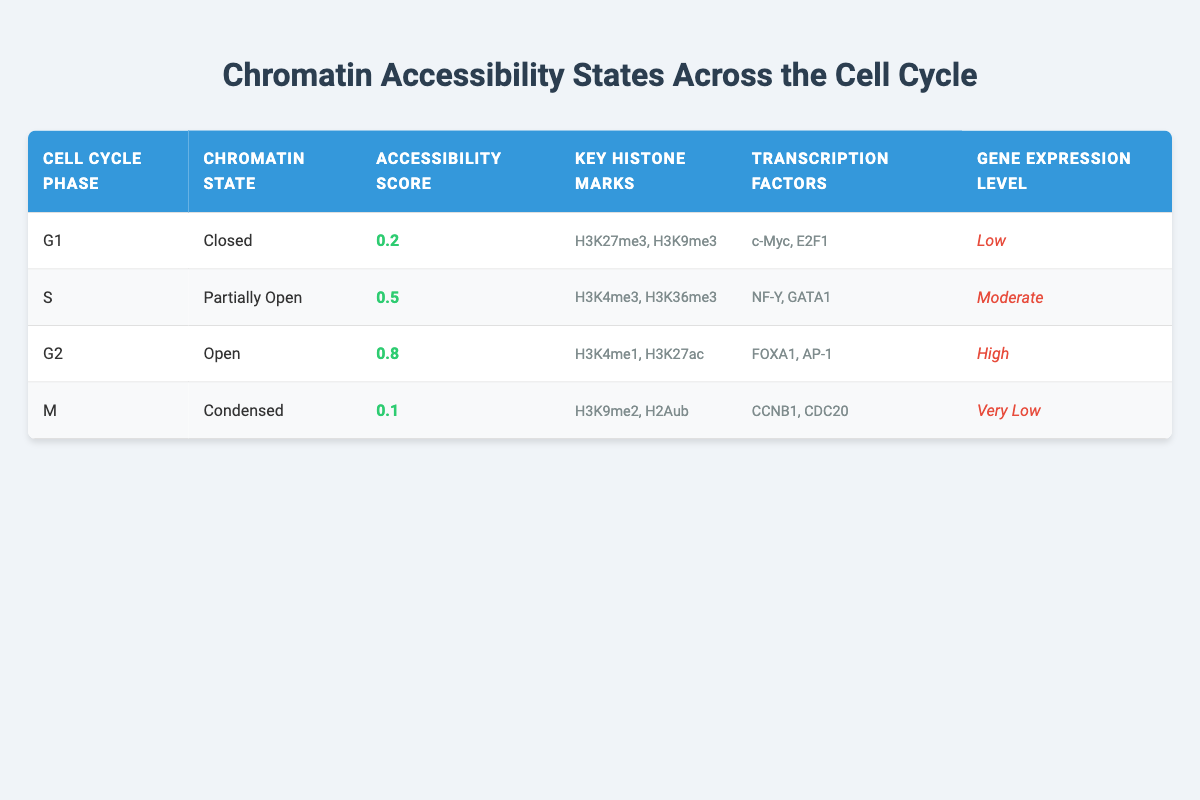What is the accessibility score during the G2 phase? In the table, for the G2 phase, the accessibility score is clearly stated as 0.8.
Answer: 0.8 Which chromatin state is associated with the lowest gene expression level? The table indicates that the M phase has a chromatin state of "Condensed" and a gene expression level described as "Very Low."
Answer: Condensed Is the chromatin state for S phase partially open? According to the information in the S phase row, the chromatin state is described as "Partially Open," so the statement is true.
Answer: Yes What are the key histone marks present during the G1 phase? The G1 phase entry lists the key histone marks as H3K27me3 and H3K9me3.
Answer: H3K27me3, H3K9me3 Based on the table, what is the average accessibility score across all phases? The scores for all phases are: G1 = 0.2, S = 0.5, G2 = 0.8, M = 0.1. The sum is 0.2 + 0.5 + 0.8 + 0.1 = 1.6, and there are 4 phases, so the average accessibility score is 1.6 divided by 4, which equals 0.4.
Answer: 0.4 During which phase is the accessibility score higher than 0.5? The table shows that only the G2 phase has an accessibility score of 0.8, which is greater than 0.5.
Answer: G2 How many transcription factors are listed for the S phase? In the S phase row, there are two transcription factors mentioned: NF-Y and GATA1.
Answer: 2 True or False: The G1 phase has a higher accessibility score than M phase. The accessibility scores for G1 and M phases are 0.2 and 0.1 respectively, so G1 does have a higher score. Thus, the statement is true.
Answer: True What is the relationship between chromatin state and gene expression level in the G2 phase? In the G2 phase, the chromatin state is "Open," and it correlates with a high gene expression level, indicating a positive relationship between the two.
Answer: Open and High 